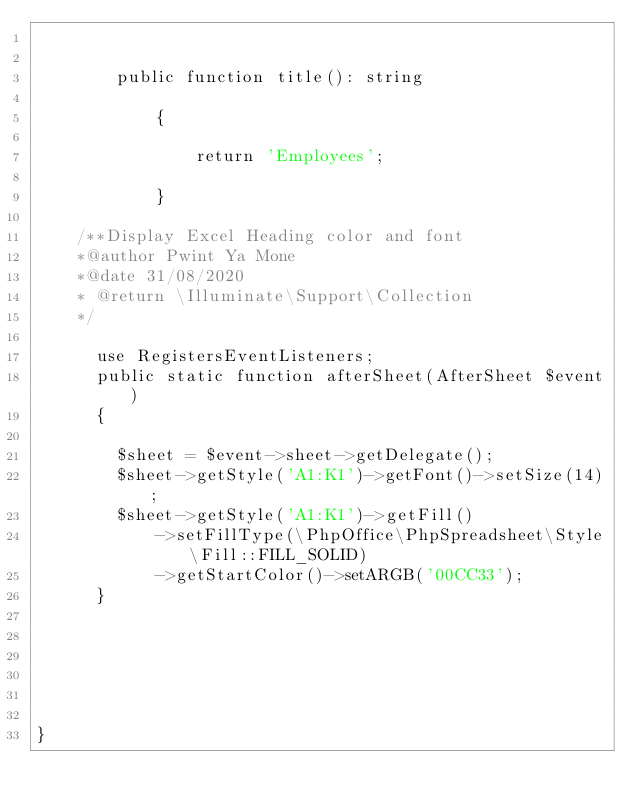<code> <loc_0><loc_0><loc_500><loc_500><_PHP_>

    	public function title(): string

    		{

    			return 'Employees';

    		}

    /**Display Excel Heading color and font
    *@author Pwint Ya Mone
    *@date 31/08/2020
    * @return \Illuminate\Support\Collection
    */

      use RegistersEventListeners;
      public static function afterSheet(AfterSheet $event)
      {
           
        $sheet = $event->sheet->getDelegate();
        $sheet->getStyle('A1:K1')->getFont()->setSize(14);
        $sheet->getStyle('A1:K1')->getFill()
            ->setFillType(\PhpOffice\PhpSpreadsheet\Style\Fill::FILL_SOLID)
            ->getStartColor()->setARGB('00CC33');
      }
   



    

}
</code> 